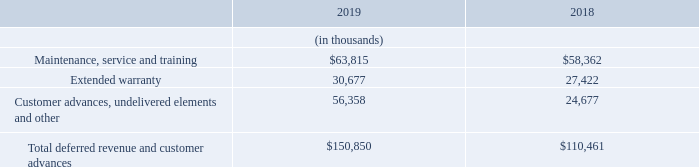Services
Teradyne services consist of extended warranties, training and application support, service agreement, post contract customer support (“PCS”) and replacement parts. Each service is recognized based on relative standalone selling price. Extended warranty, training and support, service agreements and PCS are recognized over time based on the period of service. Replacement parts are recognized at a point in time upon transfer of control to the customer.
Teradyne does not allow customer returns or provide refunds to customers for any products or services. Teradyne products include a standard 12-month warranty. This warranty is not considered a distinct performance obligation because it does not obligate Teradyne to provide a separate service to the customer and it cannot be purchased separately. Cost related to warranty are included in cost of revenues when product revenues are recognized.
As of December 31, 2019 and 2018, deferred revenue and customer advances consisted of the following and are included in the short and long-term deferred revenue and customer advances:
What does Teradyne services consist of? Extended warranties, training and application support, service agreement, post contract customer support (“pcs”) and replacement parts. Where are deferred revenue and customer advances included in? The short and long-term deferred revenue and customer advances. In which years were Total deferred revenue and customer advances calculated? 2019, 2018. In which year was Maintenance, service and training larger? 63,815>58,362
Answer: 2019. What was the change in Extended warranty from 2018 to 2019?
Answer scale should be: thousand. 30,677-27,422
Answer: 3255. What was the percentage change in Extended warranty from 2018 to 2019?
Answer scale should be: percent. (30,677-27,422)/27,422
Answer: 11.87. 